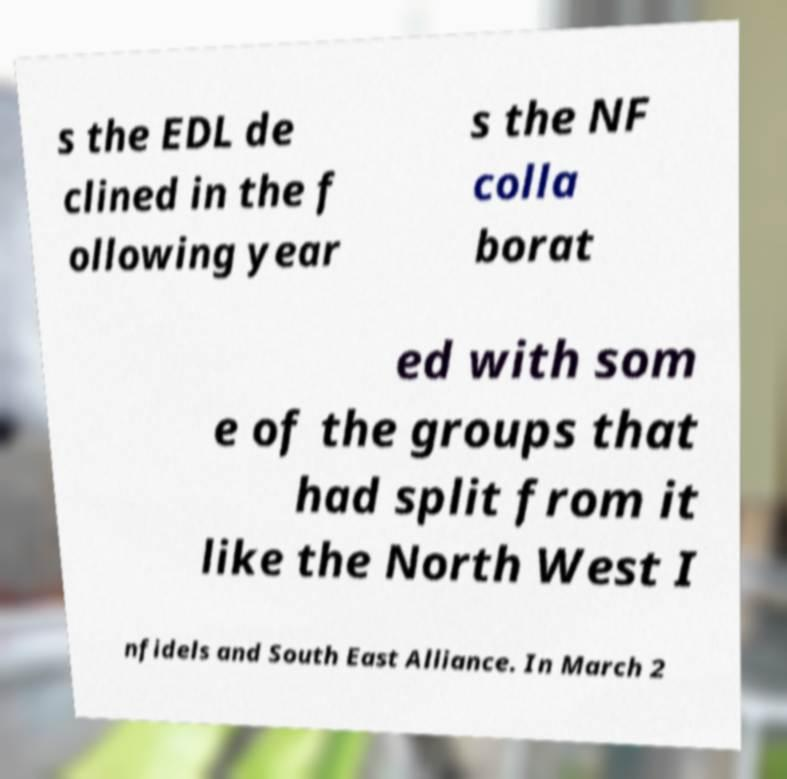For documentation purposes, I need the text within this image transcribed. Could you provide that? s the EDL de clined in the f ollowing year s the NF colla borat ed with som e of the groups that had split from it like the North West I nfidels and South East Alliance. In March 2 